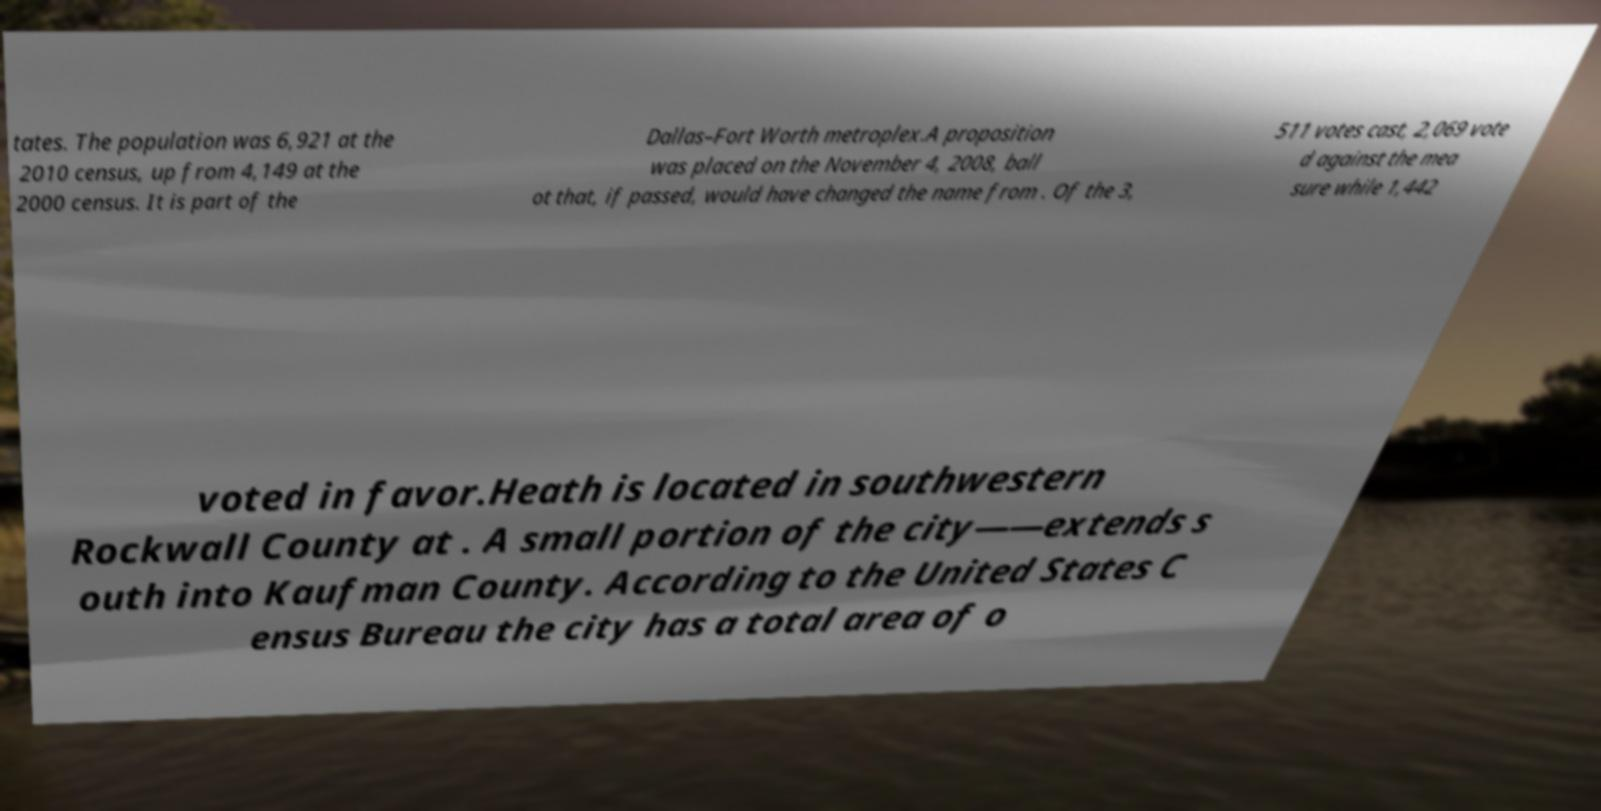There's text embedded in this image that I need extracted. Can you transcribe it verbatim? tates. The population was 6,921 at the 2010 census, up from 4,149 at the 2000 census. It is part of the Dallas–Fort Worth metroplex.A proposition was placed on the November 4, 2008, ball ot that, if passed, would have changed the name from . Of the 3, 511 votes cast, 2,069 vote d against the mea sure while 1,442 voted in favor.Heath is located in southwestern Rockwall County at . A small portion of the city——extends s outh into Kaufman County. According to the United States C ensus Bureau the city has a total area of o 